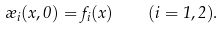Convert formula to latex. <formula><loc_0><loc_0><loc_500><loc_500>\rho _ { i } ( x , 0 ) = f _ { i } ( x ) \quad ( i = 1 , 2 ) .</formula> 